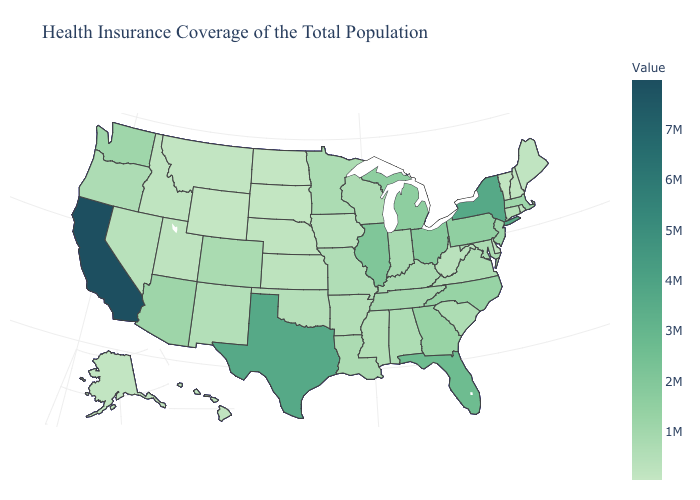Among the states that border Louisiana , does Mississippi have the highest value?
Quick response, please. No. Does Idaho have the highest value in the USA?
Be succinct. No. Does Illinois have the highest value in the MidWest?
Short answer required. Yes. Does the map have missing data?
Write a very short answer. No. 